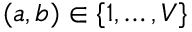<formula> <loc_0><loc_0><loc_500><loc_500>( a , b ) \in \{ 1 , \dots , V \}</formula> 